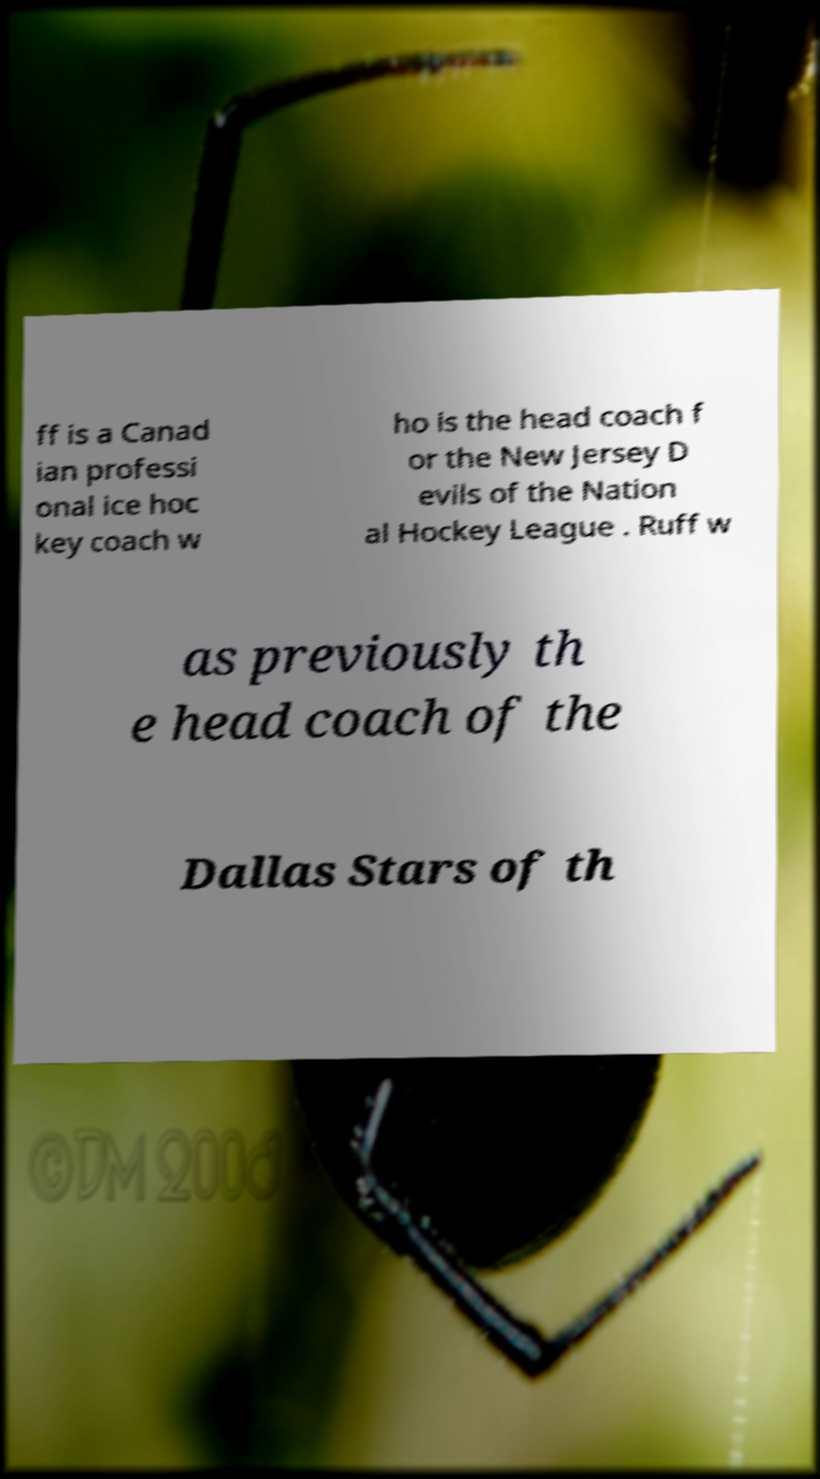Could you assist in decoding the text presented in this image and type it out clearly? ff is a Canad ian professi onal ice hoc key coach w ho is the head coach f or the New Jersey D evils of the Nation al Hockey League . Ruff w as previously th e head coach of the Dallas Stars of th 